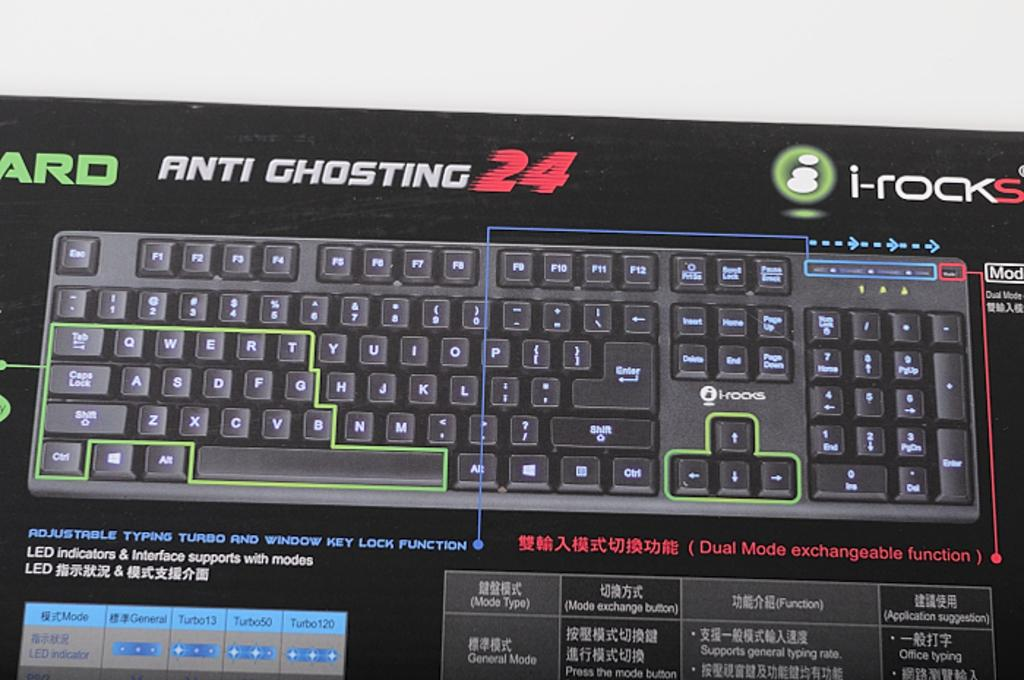<image>
Relay a brief, clear account of the picture shown. Box of a keyboard saying that it is Anti Ghosting. 